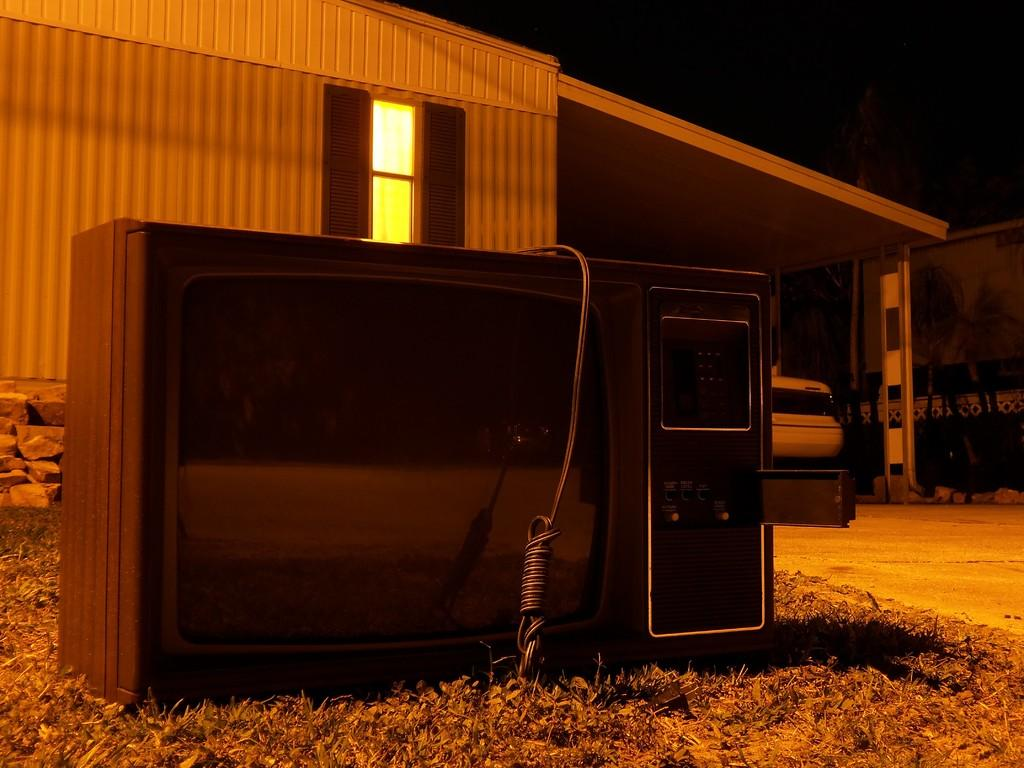What is the main object in the front of the image? There is a television in the front of the image. What is located next to the television in the front of the image? There is a cable in the front of the image. What type of natural environment is visible in the front of the image? There is grass in the front of the image. What type of structures can be seen in the background of the image? There are buildings and a shed in the background of the image. What type of natural features are present in the background of the image? There are rocks, a window, trees, and the sky in the background of the image. How many kittens are playing on the roof of the shed in the image? There are no kittens present in the image, so it is not possible to determine how many might be playing on the roof of the shed. What year is depicted in the image? The image does not contain any information about a specific year, so it is not possible to determine the year depicted. 